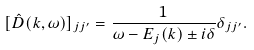<formula> <loc_0><loc_0><loc_500><loc_500>[ \hat { D } ( { k } , \omega ) ] _ { j j ^ { \prime } } = \frac { 1 } { \omega - E _ { j } ( { k } ) \pm i \delta } \delta _ { j j ^ { \prime } } .</formula> 